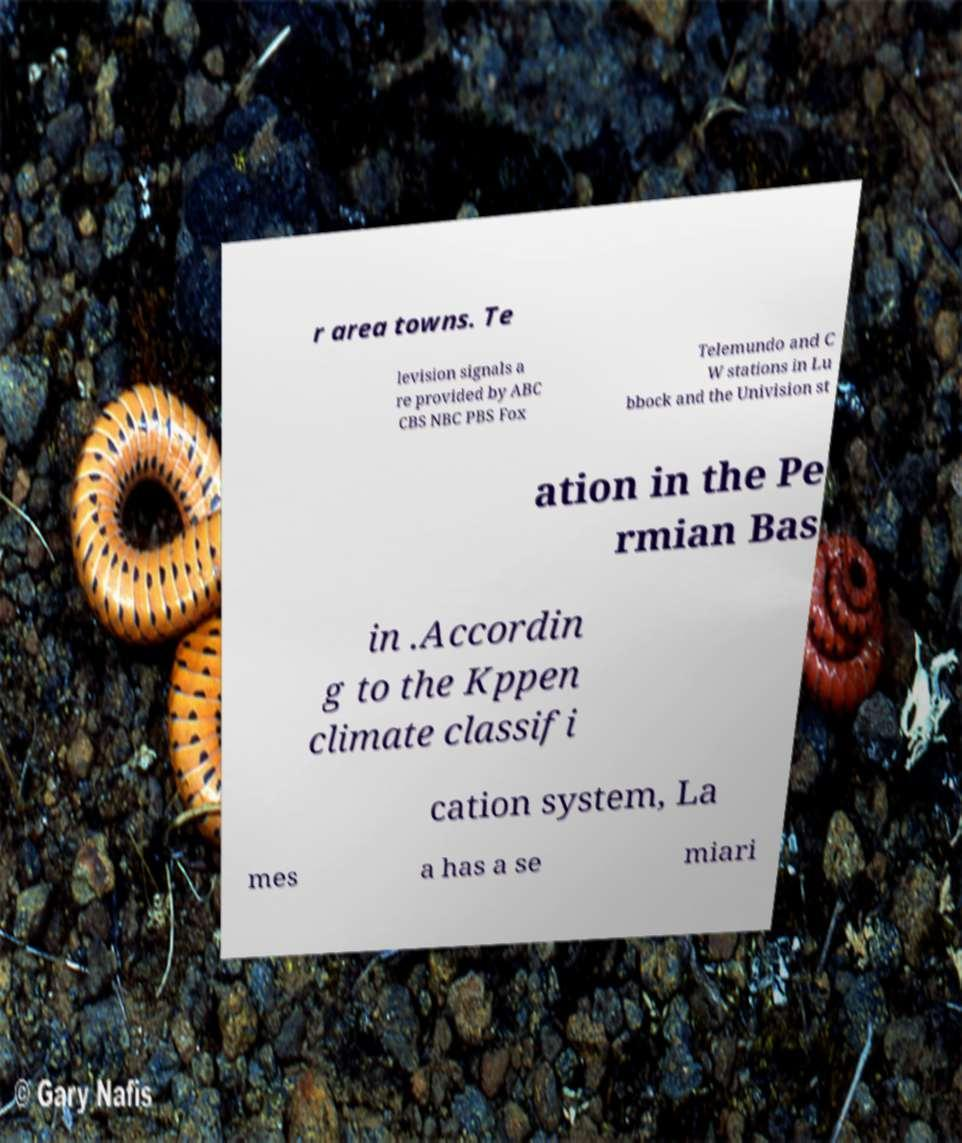Please read and relay the text visible in this image. What does it say? r area towns. Te levision signals a re provided by ABC CBS NBC PBS Fox Telemundo and C W stations in Lu bbock and the Univision st ation in the Pe rmian Bas in .Accordin g to the Kppen climate classifi cation system, La mes a has a se miari 